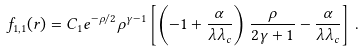<formula> <loc_0><loc_0><loc_500><loc_500>f _ { 1 , 1 } ( r ) = C _ { 1 } e ^ { - \rho / 2 } \rho ^ { \gamma - 1 } \left [ \left ( - 1 + \frac { \alpha } { \lambda \lambda _ { c } } \right ) \frac { \rho } { 2 \gamma + 1 } - \frac { \alpha } { \lambda \lambda _ { c } } \right ] \, { . }</formula> 